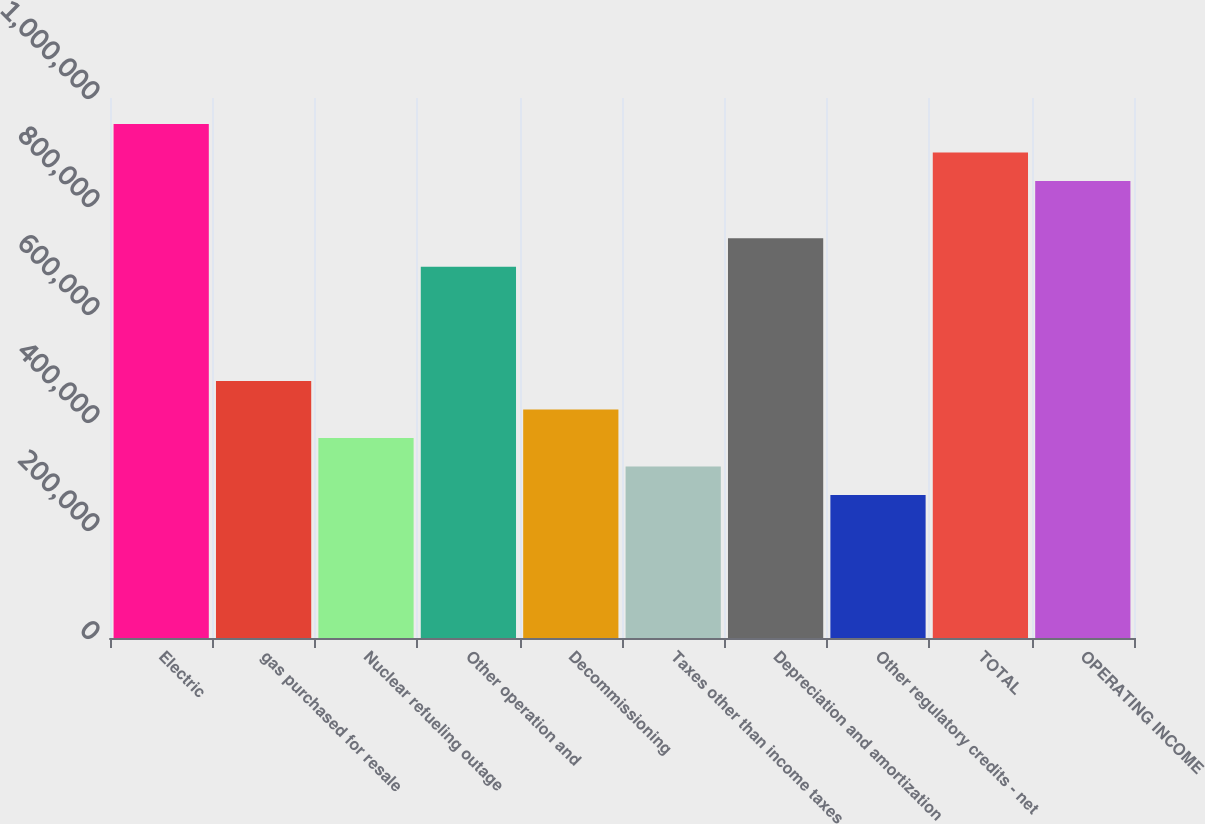Convert chart. <chart><loc_0><loc_0><loc_500><loc_500><bar_chart><fcel>Electric<fcel>gas purchased for resale<fcel>Nuclear refueling outage<fcel>Other operation and<fcel>Decommissioning<fcel>Taxes other than income taxes<fcel>Depreciation and amortization<fcel>Other regulatory credits - net<fcel>TOTAL<fcel>OPERATING INCOME<nl><fcel>951986<fcel>476124<fcel>370378<fcel>687618<fcel>423251<fcel>317504<fcel>740492<fcel>264630<fcel>899112<fcel>846239<nl></chart> 